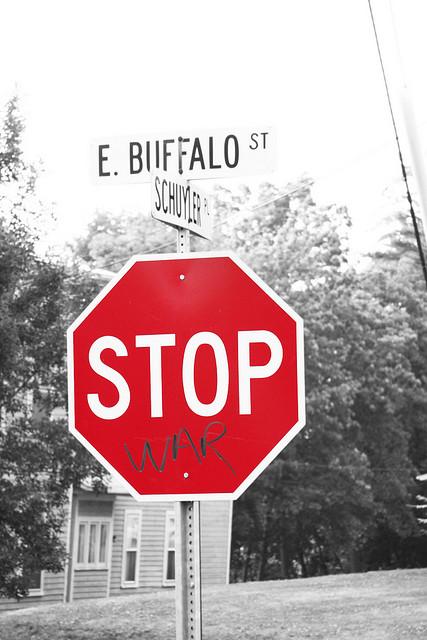What is written on the white sign?
Be succinct. E buffalo st. What does the sign say?
Write a very short answer. Stop war. What color is the sign?
Answer briefly. Red. What is on the sign under the letters?
Be succinct. War. Where is this scene taking place at?
Quick response, please. E buffalo st. What is the season?
Quick response, please. Summer. Why did someone add graffiti to this sign?
Be succinct. Protest. What street name is on the top?
Be succinct. E buffalo st. 